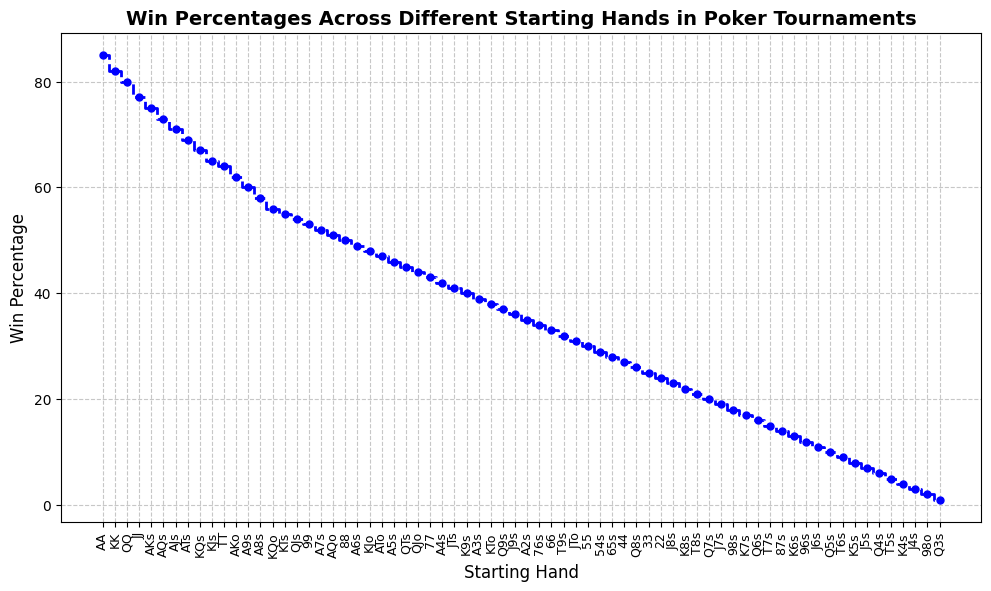What's the win percentage of the best starting hand? The best starting hand is AA, and according to the plot, its win percentage is indicated at the top.
Answer: 85 Which starting hand has a win percentage of 60%? Look for the win percentage value of 60% on the plot and find the corresponding starting hand. The plot shows that A9s has a win percentage of 60%.
Answer: A9s What is the difference in win percentages between AA and KK? AA has a win percentage of 85, and KK has 82. Subtract 82 from 85 to get the difference.
Answer: 3 What's the average win percentage of the top three starting hands? The top three starting hands are AA, KK, and QQ with win percentages 85, 82, and 80 respectively. Calculate the average by summing these percentages and dividing by three: (85 + 82 + 80) / 3.
Answer: 82.33 Which has a higher win percentage: AJs or AQs? AJs has a win percentage of 71, and AQs has 73. Since 73 is greater than 71, AQs has the higher win percentage.
Answer: AQs What is the lowest win percentage on the graph, and which starting hand does it belong to? The lowest win percentage is at the bottom of the plot. The starting hand with this win percentage is Q3s, which has a win percentage of 1.
Answer: 1, Q3s Is there a starting hand with a win percentage of 50%? If so, which one? Check the plot for the win percentage value of 50%. The starting hand with 50% win percentage is 88.
Answer: 88 What is the median win percentage of the listed starting hands? To find the median, list all win percentages in ascending order and find the middle value. There are 52 hands, so the median is the average of the 26th and 27th values: (43+42)/2.
Answer: 35.5 Does the hand Q6s have a higher win percentage than T7s? Refer to the plot for the win percentages of Q6s (16) and T7s (15). Compare these values to see Q6s being higher than T7s.
Answer: Yes What win percentage values are around JJ in the plot? JJ has a win percentage of 77. The immediate preceding and succeeding values are 80 for QQ and 75 for AKs.
Answer: 80 (QQ), 75 (AKs) 